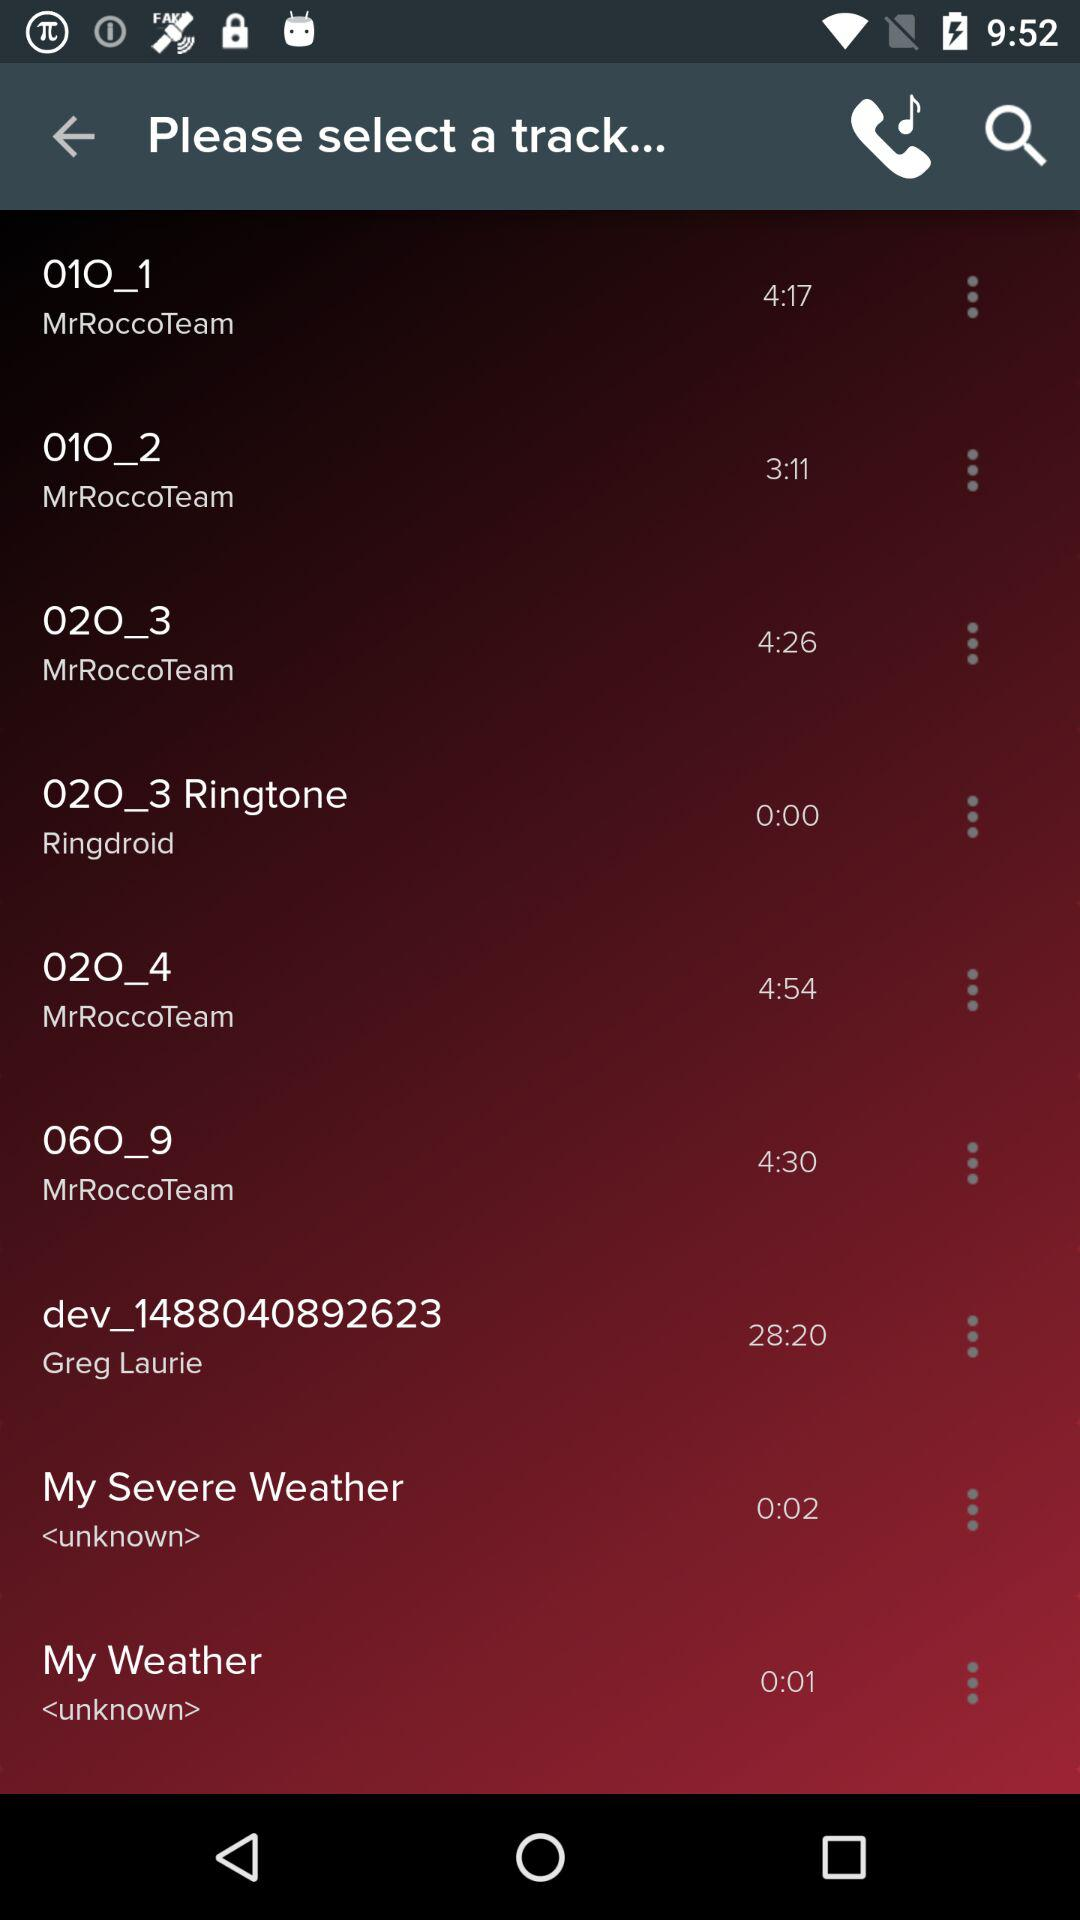What is the duration of "010_1"? The duration is 4 minutes and 17 seconds. 